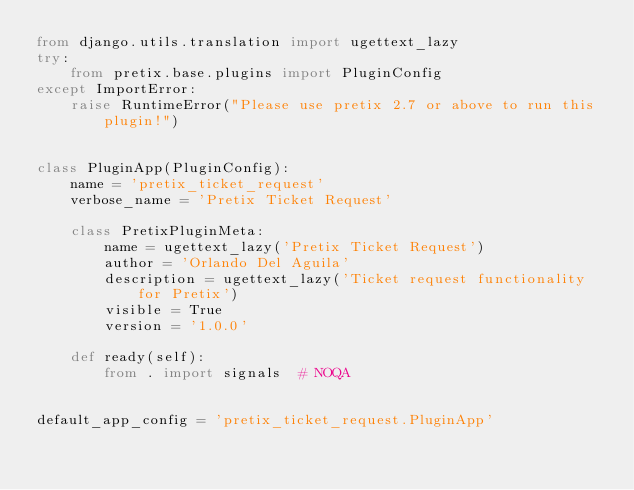Convert code to text. <code><loc_0><loc_0><loc_500><loc_500><_Python_>from django.utils.translation import ugettext_lazy
try:
    from pretix.base.plugins import PluginConfig
except ImportError:
    raise RuntimeError("Please use pretix 2.7 or above to run this plugin!")


class PluginApp(PluginConfig):
    name = 'pretix_ticket_request'
    verbose_name = 'Pretix Ticket Request'

    class PretixPluginMeta:
        name = ugettext_lazy('Pretix Ticket Request')
        author = 'Orlando Del Aguila'
        description = ugettext_lazy('Ticket request functionality for Pretix')
        visible = True
        version = '1.0.0'

    def ready(self):
        from . import signals  # NOQA


default_app_config = 'pretix_ticket_request.PluginApp'
</code> 